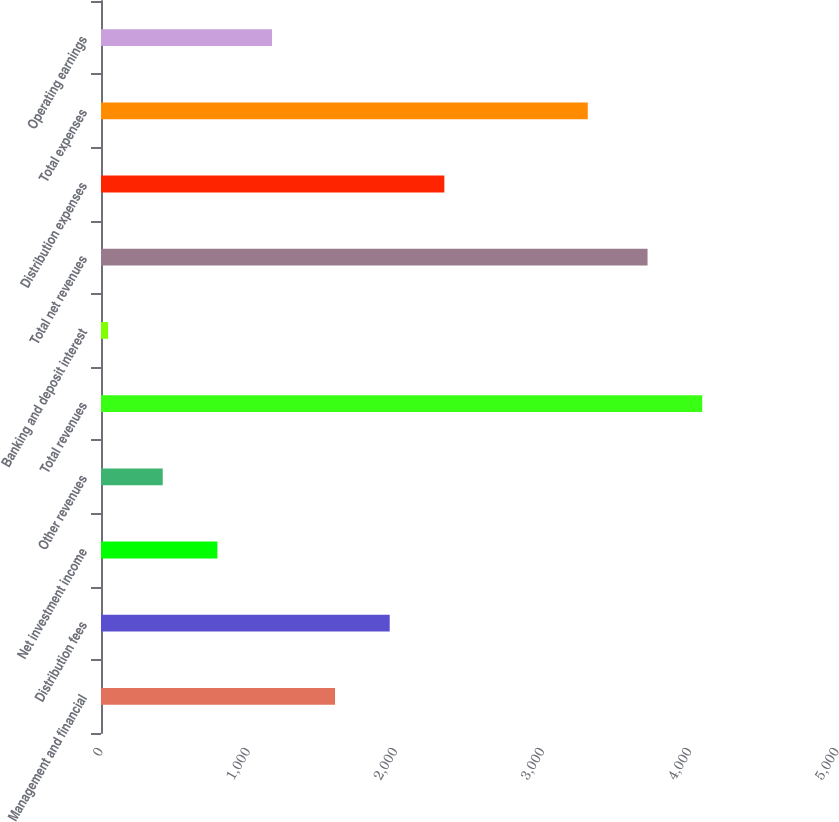Convert chart to OTSL. <chart><loc_0><loc_0><loc_500><loc_500><bar_chart><fcel>Management and financial<fcel>Distribution fees<fcel>Net investment income<fcel>Other revenues<fcel>Total revenues<fcel>Banking and deposit interest<fcel>Total net revenues<fcel>Distribution expenses<fcel>Total expenses<fcel>Operating earnings<nl><fcel>1590<fcel>1961.3<fcel>790.6<fcel>419.3<fcel>4084.3<fcel>48<fcel>3713<fcel>2332.6<fcel>3307<fcel>1161.9<nl></chart> 